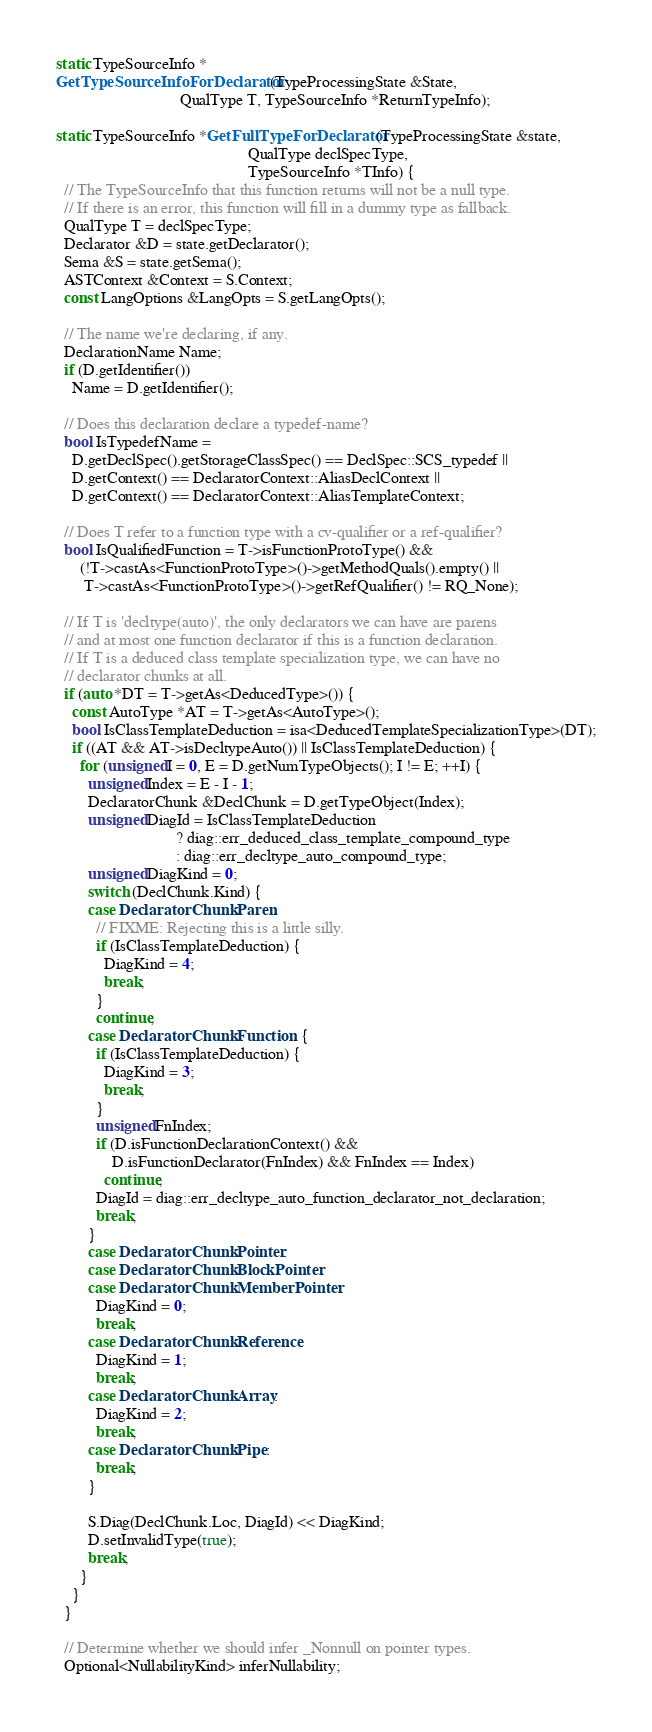Convert code to text. <code><loc_0><loc_0><loc_500><loc_500><_C++_>static TypeSourceInfo *
GetTypeSourceInfoForDeclarator(TypeProcessingState &State,
                               QualType T, TypeSourceInfo *ReturnTypeInfo);

static TypeSourceInfo *GetFullTypeForDeclarator(TypeProcessingState &state,
                                                QualType declSpecType,
                                                TypeSourceInfo *TInfo) {
  // The TypeSourceInfo that this function returns will not be a null type.
  // If there is an error, this function will fill in a dummy type as fallback.
  QualType T = declSpecType;
  Declarator &D = state.getDeclarator();
  Sema &S = state.getSema();
  ASTContext &Context = S.Context;
  const LangOptions &LangOpts = S.getLangOpts();

  // The name we're declaring, if any.
  DeclarationName Name;
  if (D.getIdentifier())
    Name = D.getIdentifier();

  // Does this declaration declare a typedef-name?
  bool IsTypedefName =
    D.getDeclSpec().getStorageClassSpec() == DeclSpec::SCS_typedef ||
    D.getContext() == DeclaratorContext::AliasDeclContext ||
    D.getContext() == DeclaratorContext::AliasTemplateContext;

  // Does T refer to a function type with a cv-qualifier or a ref-qualifier?
  bool IsQualifiedFunction = T->isFunctionProtoType() &&
      (!T->castAs<FunctionProtoType>()->getMethodQuals().empty() ||
       T->castAs<FunctionProtoType>()->getRefQualifier() != RQ_None);

  // If T is 'decltype(auto)', the only declarators we can have are parens
  // and at most one function declarator if this is a function declaration.
  // If T is a deduced class template specialization type, we can have no
  // declarator chunks at all.
  if (auto *DT = T->getAs<DeducedType>()) {
    const AutoType *AT = T->getAs<AutoType>();
    bool IsClassTemplateDeduction = isa<DeducedTemplateSpecializationType>(DT);
    if ((AT && AT->isDecltypeAuto()) || IsClassTemplateDeduction) {
      for (unsigned I = 0, E = D.getNumTypeObjects(); I != E; ++I) {
        unsigned Index = E - I - 1;
        DeclaratorChunk &DeclChunk = D.getTypeObject(Index);
        unsigned DiagId = IsClassTemplateDeduction
                              ? diag::err_deduced_class_template_compound_type
                              : diag::err_decltype_auto_compound_type;
        unsigned DiagKind = 0;
        switch (DeclChunk.Kind) {
        case DeclaratorChunk::Paren:
          // FIXME: Rejecting this is a little silly.
          if (IsClassTemplateDeduction) {
            DiagKind = 4;
            break;
          }
          continue;
        case DeclaratorChunk::Function: {
          if (IsClassTemplateDeduction) {
            DiagKind = 3;
            break;
          }
          unsigned FnIndex;
          if (D.isFunctionDeclarationContext() &&
              D.isFunctionDeclarator(FnIndex) && FnIndex == Index)
            continue;
          DiagId = diag::err_decltype_auto_function_declarator_not_declaration;
          break;
        }
        case DeclaratorChunk::Pointer:
        case DeclaratorChunk::BlockPointer:
        case DeclaratorChunk::MemberPointer:
          DiagKind = 0;
          break;
        case DeclaratorChunk::Reference:
          DiagKind = 1;
          break;
        case DeclaratorChunk::Array:
          DiagKind = 2;
          break;
        case DeclaratorChunk::Pipe:
          break;
        }

        S.Diag(DeclChunk.Loc, DiagId) << DiagKind;
        D.setInvalidType(true);
        break;
      }
    }
  }

  // Determine whether we should infer _Nonnull on pointer types.
  Optional<NullabilityKind> inferNullability;</code> 